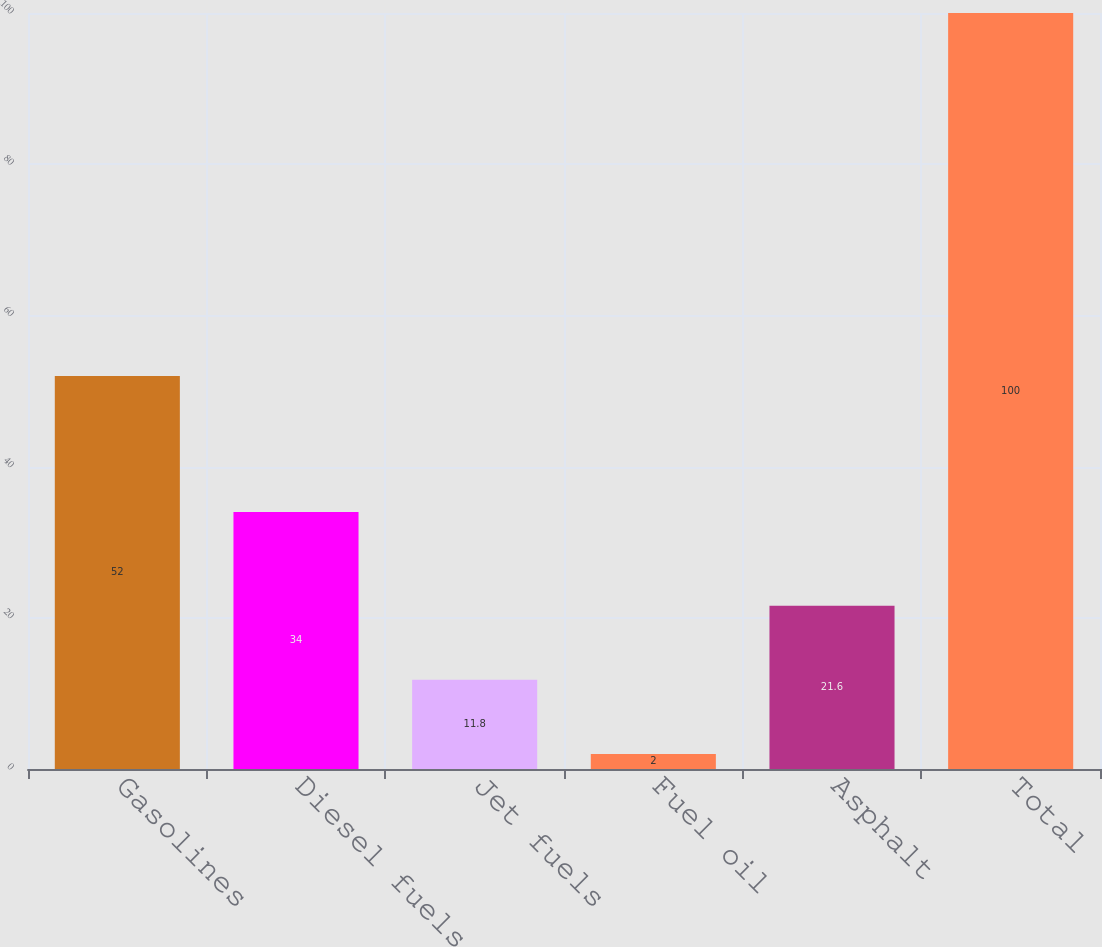Convert chart. <chart><loc_0><loc_0><loc_500><loc_500><bar_chart><fcel>Gasolines<fcel>Diesel fuels<fcel>Jet fuels<fcel>Fuel oil<fcel>Asphalt<fcel>Total<nl><fcel>52<fcel>34<fcel>11.8<fcel>2<fcel>21.6<fcel>100<nl></chart> 